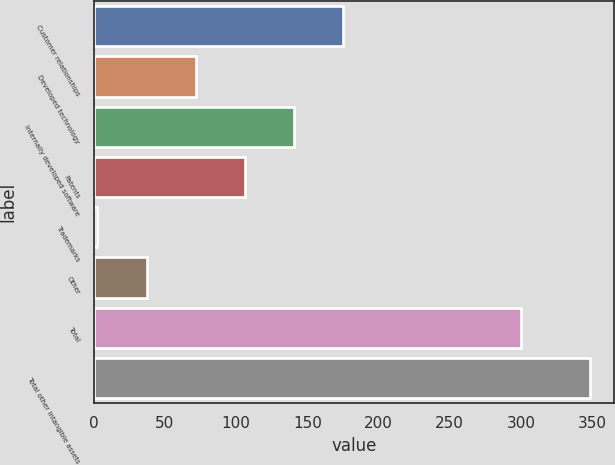Convert chart. <chart><loc_0><loc_0><loc_500><loc_500><bar_chart><fcel>Customer relationships<fcel>Developed technology<fcel>Internally developed software<fcel>Patents<fcel>Trademarks<fcel>Other<fcel>Total<fcel>Total other intangible assets<nl><fcel>175.4<fcel>71.72<fcel>140.84<fcel>106.28<fcel>2.6<fcel>37.16<fcel>299.7<fcel>348.2<nl></chart> 